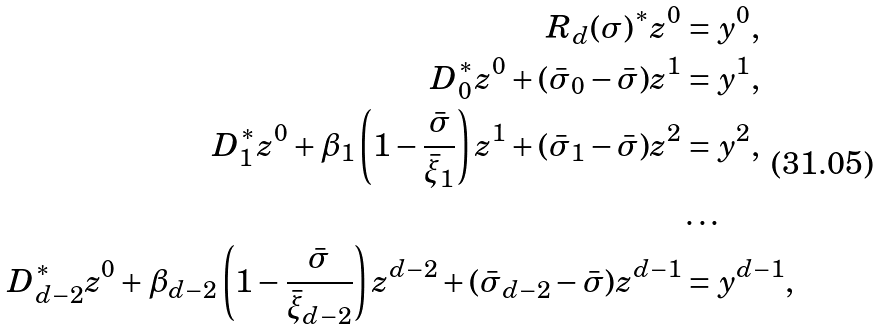Convert formula to latex. <formula><loc_0><loc_0><loc_500><loc_500>R _ { d } ( \sigma ) ^ { * } z ^ { 0 } & = y ^ { 0 } , \\ D _ { 0 } ^ { * } z ^ { 0 } + ( \bar { \sigma } _ { 0 } - \bar { \sigma } ) z ^ { 1 } & = y ^ { 1 } , \\ D _ { 1 } ^ { * } z ^ { 0 } + \beta _ { 1 } \left ( 1 - \frac { \bar { \sigma } } { \bar { \xi } _ { 1 } } \right ) z ^ { 1 } + ( \bar { \sigma } _ { 1 } - \bar { \sigma } ) z ^ { 2 } & = y ^ { 2 } , \\ & \dots \\ D _ { d - 2 } ^ { * } z ^ { 0 } + \beta _ { d - 2 } \left ( 1 - \frac { \bar { \sigma } } { \bar { \xi } _ { d - 2 } } \right ) z ^ { d - 2 } + ( \bar { \sigma } _ { d - 2 } - \bar { \sigma } ) z ^ { d - 1 } & = y ^ { d - 1 } , \\</formula> 